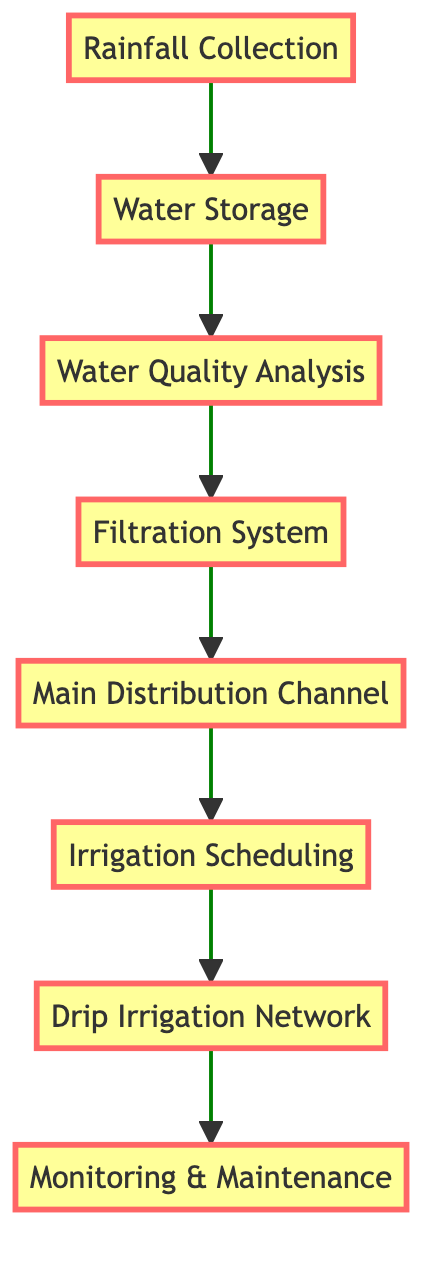What is the first step in the flow chart? The first step is "Rainfall Collection," which is directly mentioned at the bottom of the flow chart.
Answer: Rainfall Collection How many total nodes are in the diagram? There are eight nodes in total: Rainfall Collection, Water Storage, Water Quality Analysis, Filtration System, Main Distribution Channel, Irrigation Scheduling, Drip Irrigation Network, and Monitoring & Maintenance. Counting each distinct step gives us this total.
Answer: Eight Which step occurs directly after Water Storage? The step that occurs directly after Water Storage is "Water Quality Analysis," indicated by the arrow leading from Water Storage to Water Quality Analysis.
Answer: Water Quality Analysis What connects "Filtration System" and "Main Distribution Channel"? The arrow connects "Filtration System" to "Main Distribution Channel," indicating the flow of water after filtration towards distribution.
Answer: Filtration System In the sequence of steps, which one is the last? The last step in the sequence is "Monitoring & Maintenance," which is at the top of the flow chart as the final point of the water management process.
Answer: Monitoring & Maintenance What is the purpose of the "Filtration System"? The purpose of the Filtration System is to purify water before its usage in irrigation, protecting both crops and ancient ruins. The description directly states this function.
Answer: Purify water Which process requires a timetable for distribution? The process that requires a timetable for distribution is "Irrigation Scheduling," which is specifically mentioned as involving the creation of a timetable considering various factors.
Answer: Irrigation Scheduling What ensures the harvested rainwater is safe for use? "Water Quality Analysis" ensures the harvested rainwater is tested for contaminants, which is crucial for determining safety for irrigation.
Answer: Water Quality Analysis 